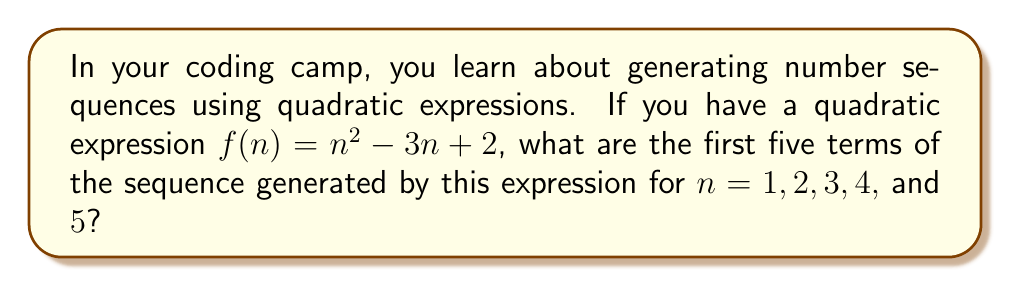What is the answer to this math problem? Let's calculate the value of $f(n)$ for each value of $n$ from 1 to 5:

1. For $n = 1$:
   $f(1) = 1^2 - 3(1) + 2 = 1 - 3 + 2 = 0$

2. For $n = 2$:
   $f(2) = 2^2 - 3(2) + 2 = 4 - 6 + 2 = 0$

3. For $n = 3$:
   $f(3) = 3^2 - 3(3) + 2 = 9 - 9 + 2 = 2$

4. For $n = 4$:
   $f(4) = 4^2 - 3(4) + 2 = 16 - 12 + 2 = 6$

5. For $n = 5$:
   $f(5) = 5^2 - 3(5) + 2 = 25 - 15 + 2 = 12$

Therefore, the first five terms of the sequence are 0, 0, 2, 6, and 12.
Answer: 0, 0, 2, 6, 12 